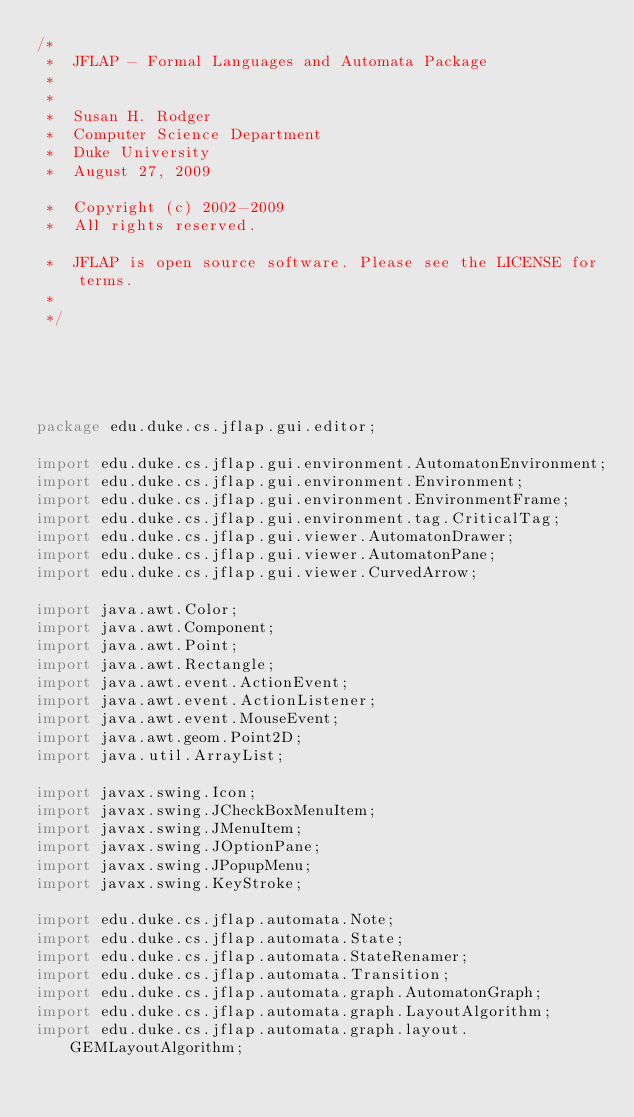Convert code to text. <code><loc_0><loc_0><loc_500><loc_500><_Java_>/*
 *  JFLAP - Formal Languages and Automata Package
 * 
 * 
 *  Susan H. Rodger
 *  Computer Science Department
 *  Duke University
 *  August 27, 2009

 *  Copyright (c) 2002-2009
 *  All rights reserved.

 *  JFLAP is open source software. Please see the LICENSE for terms.
 *
 */





package edu.duke.cs.jflap.gui.editor;

import edu.duke.cs.jflap.gui.environment.AutomatonEnvironment;
import edu.duke.cs.jflap.gui.environment.Environment;
import edu.duke.cs.jflap.gui.environment.EnvironmentFrame;
import edu.duke.cs.jflap.gui.environment.tag.CriticalTag;
import edu.duke.cs.jflap.gui.viewer.AutomatonDrawer;
import edu.duke.cs.jflap.gui.viewer.AutomatonPane;
import edu.duke.cs.jflap.gui.viewer.CurvedArrow;

import java.awt.Color;
import java.awt.Component;
import java.awt.Point;
import java.awt.Rectangle;
import java.awt.event.ActionEvent;
import java.awt.event.ActionListener;
import java.awt.event.MouseEvent;
import java.awt.geom.Point2D;
import java.util.ArrayList;

import javax.swing.Icon;
import javax.swing.JCheckBoxMenuItem;
import javax.swing.JMenuItem;
import javax.swing.JOptionPane;
import javax.swing.JPopupMenu;
import javax.swing.KeyStroke;

import edu.duke.cs.jflap.automata.Note;
import edu.duke.cs.jflap.automata.State;
import edu.duke.cs.jflap.automata.StateRenamer;
import edu.duke.cs.jflap.automata.Transition;
import edu.duke.cs.jflap.automata.graph.AutomatonGraph;
import edu.duke.cs.jflap.automata.graph.LayoutAlgorithm;
import edu.duke.cs.jflap.automata.graph.layout.GEMLayoutAlgorithm;</code> 